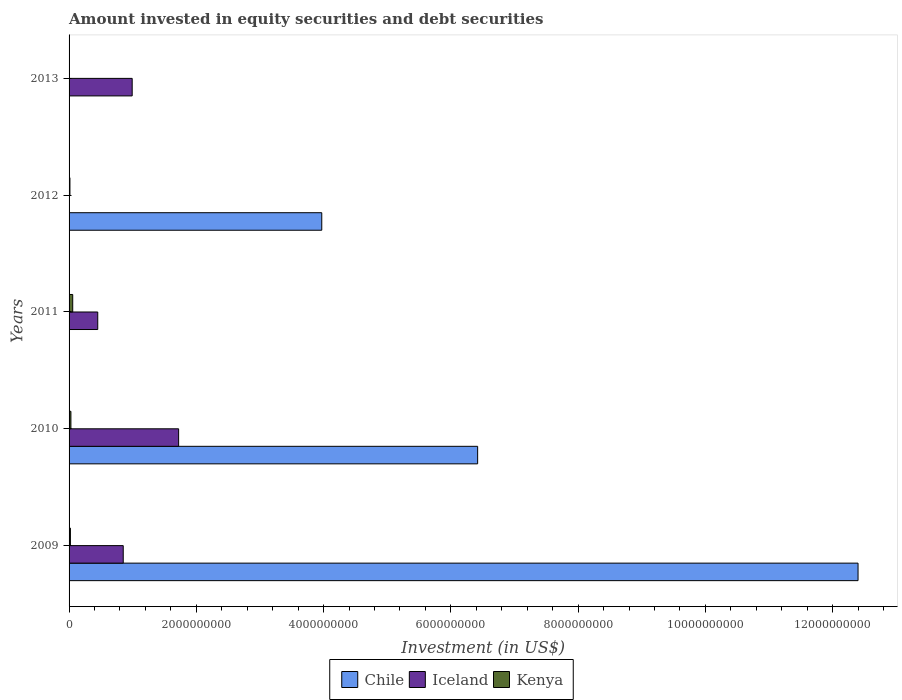How many different coloured bars are there?
Your answer should be very brief. 3. How many bars are there on the 3rd tick from the top?
Offer a terse response. 2. What is the amount invested in equity securities and debt securities in Kenya in 2009?
Provide a succinct answer. 2.09e+07. Across all years, what is the maximum amount invested in equity securities and debt securities in Iceland?
Provide a succinct answer. 1.72e+09. Across all years, what is the minimum amount invested in equity securities and debt securities in Kenya?
Your answer should be very brief. 0. What is the total amount invested in equity securities and debt securities in Iceland in the graph?
Keep it short and to the point. 4.02e+09. What is the difference between the amount invested in equity securities and debt securities in Kenya in 2011 and that in 2012?
Provide a succinct answer. 4.38e+07. What is the difference between the amount invested in equity securities and debt securities in Iceland in 2009 and the amount invested in equity securities and debt securities in Kenya in 2013?
Provide a succinct answer. 8.51e+08. What is the average amount invested in equity securities and debt securities in Kenya per year?
Make the answer very short. 2.42e+07. In the year 2009, what is the difference between the amount invested in equity securities and debt securities in Kenya and amount invested in equity securities and debt securities in Iceland?
Offer a very short reply. -8.30e+08. In how many years, is the amount invested in equity securities and debt securities in Iceland greater than 4000000000 US$?
Your answer should be compact. 0. What is the ratio of the amount invested in equity securities and debt securities in Kenya in 2009 to that in 2012?
Provide a short and direct response. 1.54. What is the difference between the highest and the second highest amount invested in equity securities and debt securities in Iceland?
Your answer should be compact. 7.30e+08. What is the difference between the highest and the lowest amount invested in equity securities and debt securities in Kenya?
Your answer should be compact. 5.74e+07. In how many years, is the amount invested in equity securities and debt securities in Iceland greater than the average amount invested in equity securities and debt securities in Iceland taken over all years?
Offer a very short reply. 3. Is the sum of the amount invested in equity securities and debt securities in Kenya in 2009 and 2011 greater than the maximum amount invested in equity securities and debt securities in Iceland across all years?
Provide a succinct answer. No. Is it the case that in every year, the sum of the amount invested in equity securities and debt securities in Kenya and amount invested in equity securities and debt securities in Iceland is greater than the amount invested in equity securities and debt securities in Chile?
Give a very brief answer. No. How many bars are there?
Make the answer very short. 11. Are all the bars in the graph horizontal?
Your answer should be very brief. Yes. How many years are there in the graph?
Provide a succinct answer. 5. What is the difference between two consecutive major ticks on the X-axis?
Make the answer very short. 2.00e+09. Are the values on the major ticks of X-axis written in scientific E-notation?
Make the answer very short. No. How many legend labels are there?
Provide a short and direct response. 3. What is the title of the graph?
Your answer should be compact. Amount invested in equity securities and debt securities. Does "Korea (Republic)" appear as one of the legend labels in the graph?
Offer a terse response. No. What is the label or title of the X-axis?
Your answer should be very brief. Investment (in US$). What is the Investment (in US$) in Chile in 2009?
Give a very brief answer. 1.24e+1. What is the Investment (in US$) of Iceland in 2009?
Offer a very short reply. 8.51e+08. What is the Investment (in US$) of Kenya in 2009?
Offer a very short reply. 2.09e+07. What is the Investment (in US$) in Chile in 2010?
Offer a terse response. 6.42e+09. What is the Investment (in US$) in Iceland in 2010?
Your answer should be compact. 1.72e+09. What is the Investment (in US$) in Kenya in 2010?
Give a very brief answer. 2.90e+07. What is the Investment (in US$) in Iceland in 2011?
Give a very brief answer. 4.51e+08. What is the Investment (in US$) in Kenya in 2011?
Give a very brief answer. 5.74e+07. What is the Investment (in US$) of Chile in 2012?
Give a very brief answer. 3.97e+09. What is the Investment (in US$) of Kenya in 2012?
Your answer should be compact. 1.36e+07. What is the Investment (in US$) of Chile in 2013?
Offer a very short reply. 0. What is the Investment (in US$) of Iceland in 2013?
Your response must be concise. 9.92e+08. Across all years, what is the maximum Investment (in US$) of Chile?
Give a very brief answer. 1.24e+1. Across all years, what is the maximum Investment (in US$) in Iceland?
Your response must be concise. 1.72e+09. Across all years, what is the maximum Investment (in US$) in Kenya?
Ensure brevity in your answer.  5.74e+07. Across all years, what is the minimum Investment (in US$) in Chile?
Offer a very short reply. 0. What is the total Investment (in US$) in Chile in the graph?
Provide a short and direct response. 2.28e+1. What is the total Investment (in US$) in Iceland in the graph?
Keep it short and to the point. 4.02e+09. What is the total Investment (in US$) in Kenya in the graph?
Your answer should be very brief. 1.21e+08. What is the difference between the Investment (in US$) in Chile in 2009 and that in 2010?
Offer a very short reply. 5.98e+09. What is the difference between the Investment (in US$) of Iceland in 2009 and that in 2010?
Offer a terse response. -8.70e+08. What is the difference between the Investment (in US$) of Kenya in 2009 and that in 2010?
Your response must be concise. -8.07e+06. What is the difference between the Investment (in US$) in Iceland in 2009 and that in 2011?
Your answer should be compact. 4.01e+08. What is the difference between the Investment (in US$) of Kenya in 2009 and that in 2011?
Your answer should be very brief. -3.65e+07. What is the difference between the Investment (in US$) in Chile in 2009 and that in 2012?
Your answer should be compact. 8.43e+09. What is the difference between the Investment (in US$) of Kenya in 2009 and that in 2012?
Keep it short and to the point. 7.29e+06. What is the difference between the Investment (in US$) in Iceland in 2009 and that in 2013?
Provide a succinct answer. -1.41e+08. What is the difference between the Investment (in US$) of Iceland in 2010 and that in 2011?
Provide a succinct answer. 1.27e+09. What is the difference between the Investment (in US$) in Kenya in 2010 and that in 2011?
Make the answer very short. -2.84e+07. What is the difference between the Investment (in US$) in Chile in 2010 and that in 2012?
Provide a short and direct response. 2.45e+09. What is the difference between the Investment (in US$) in Kenya in 2010 and that in 2012?
Your response must be concise. 1.54e+07. What is the difference between the Investment (in US$) of Iceland in 2010 and that in 2013?
Give a very brief answer. 7.30e+08. What is the difference between the Investment (in US$) of Kenya in 2011 and that in 2012?
Make the answer very short. 4.38e+07. What is the difference between the Investment (in US$) of Iceland in 2011 and that in 2013?
Offer a very short reply. -5.41e+08. What is the difference between the Investment (in US$) in Chile in 2009 and the Investment (in US$) in Iceland in 2010?
Your answer should be very brief. 1.07e+1. What is the difference between the Investment (in US$) of Chile in 2009 and the Investment (in US$) of Kenya in 2010?
Offer a very short reply. 1.24e+1. What is the difference between the Investment (in US$) of Iceland in 2009 and the Investment (in US$) of Kenya in 2010?
Make the answer very short. 8.22e+08. What is the difference between the Investment (in US$) in Chile in 2009 and the Investment (in US$) in Iceland in 2011?
Provide a succinct answer. 1.19e+1. What is the difference between the Investment (in US$) of Chile in 2009 and the Investment (in US$) of Kenya in 2011?
Provide a short and direct response. 1.23e+1. What is the difference between the Investment (in US$) of Iceland in 2009 and the Investment (in US$) of Kenya in 2011?
Give a very brief answer. 7.94e+08. What is the difference between the Investment (in US$) of Chile in 2009 and the Investment (in US$) of Kenya in 2012?
Your response must be concise. 1.24e+1. What is the difference between the Investment (in US$) in Iceland in 2009 and the Investment (in US$) in Kenya in 2012?
Provide a succinct answer. 8.38e+08. What is the difference between the Investment (in US$) of Chile in 2009 and the Investment (in US$) of Iceland in 2013?
Give a very brief answer. 1.14e+1. What is the difference between the Investment (in US$) of Chile in 2010 and the Investment (in US$) of Iceland in 2011?
Your answer should be very brief. 5.97e+09. What is the difference between the Investment (in US$) of Chile in 2010 and the Investment (in US$) of Kenya in 2011?
Ensure brevity in your answer.  6.36e+09. What is the difference between the Investment (in US$) in Iceland in 2010 and the Investment (in US$) in Kenya in 2011?
Your response must be concise. 1.66e+09. What is the difference between the Investment (in US$) in Chile in 2010 and the Investment (in US$) in Kenya in 2012?
Provide a short and direct response. 6.41e+09. What is the difference between the Investment (in US$) of Iceland in 2010 and the Investment (in US$) of Kenya in 2012?
Your response must be concise. 1.71e+09. What is the difference between the Investment (in US$) of Chile in 2010 and the Investment (in US$) of Iceland in 2013?
Make the answer very short. 5.43e+09. What is the difference between the Investment (in US$) in Iceland in 2011 and the Investment (in US$) in Kenya in 2012?
Your answer should be very brief. 4.37e+08. What is the difference between the Investment (in US$) of Chile in 2012 and the Investment (in US$) of Iceland in 2013?
Keep it short and to the point. 2.98e+09. What is the average Investment (in US$) in Chile per year?
Provide a succinct answer. 4.56e+09. What is the average Investment (in US$) in Iceland per year?
Provide a short and direct response. 8.03e+08. What is the average Investment (in US$) in Kenya per year?
Ensure brevity in your answer.  2.42e+07. In the year 2009, what is the difference between the Investment (in US$) in Chile and Investment (in US$) in Iceland?
Keep it short and to the point. 1.15e+1. In the year 2009, what is the difference between the Investment (in US$) of Chile and Investment (in US$) of Kenya?
Provide a short and direct response. 1.24e+1. In the year 2009, what is the difference between the Investment (in US$) in Iceland and Investment (in US$) in Kenya?
Offer a very short reply. 8.30e+08. In the year 2010, what is the difference between the Investment (in US$) of Chile and Investment (in US$) of Iceland?
Offer a very short reply. 4.70e+09. In the year 2010, what is the difference between the Investment (in US$) of Chile and Investment (in US$) of Kenya?
Ensure brevity in your answer.  6.39e+09. In the year 2010, what is the difference between the Investment (in US$) of Iceland and Investment (in US$) of Kenya?
Offer a terse response. 1.69e+09. In the year 2011, what is the difference between the Investment (in US$) in Iceland and Investment (in US$) in Kenya?
Offer a terse response. 3.93e+08. In the year 2012, what is the difference between the Investment (in US$) of Chile and Investment (in US$) of Kenya?
Offer a terse response. 3.96e+09. What is the ratio of the Investment (in US$) in Chile in 2009 to that in 2010?
Provide a succinct answer. 1.93. What is the ratio of the Investment (in US$) of Iceland in 2009 to that in 2010?
Your answer should be very brief. 0.49. What is the ratio of the Investment (in US$) in Kenya in 2009 to that in 2010?
Provide a succinct answer. 0.72. What is the ratio of the Investment (in US$) of Iceland in 2009 to that in 2011?
Your answer should be very brief. 1.89. What is the ratio of the Investment (in US$) of Kenya in 2009 to that in 2011?
Your response must be concise. 0.36. What is the ratio of the Investment (in US$) of Chile in 2009 to that in 2012?
Keep it short and to the point. 3.12. What is the ratio of the Investment (in US$) in Kenya in 2009 to that in 2012?
Keep it short and to the point. 1.54. What is the ratio of the Investment (in US$) in Iceland in 2009 to that in 2013?
Give a very brief answer. 0.86. What is the ratio of the Investment (in US$) of Iceland in 2010 to that in 2011?
Keep it short and to the point. 3.82. What is the ratio of the Investment (in US$) of Kenya in 2010 to that in 2011?
Your response must be concise. 0.5. What is the ratio of the Investment (in US$) in Chile in 2010 to that in 2012?
Give a very brief answer. 1.62. What is the ratio of the Investment (in US$) in Kenya in 2010 to that in 2012?
Offer a terse response. 2.13. What is the ratio of the Investment (in US$) of Iceland in 2010 to that in 2013?
Offer a terse response. 1.74. What is the ratio of the Investment (in US$) in Kenya in 2011 to that in 2012?
Ensure brevity in your answer.  4.22. What is the ratio of the Investment (in US$) in Iceland in 2011 to that in 2013?
Make the answer very short. 0.45. What is the difference between the highest and the second highest Investment (in US$) of Chile?
Make the answer very short. 5.98e+09. What is the difference between the highest and the second highest Investment (in US$) of Iceland?
Provide a short and direct response. 7.30e+08. What is the difference between the highest and the second highest Investment (in US$) of Kenya?
Keep it short and to the point. 2.84e+07. What is the difference between the highest and the lowest Investment (in US$) of Chile?
Your response must be concise. 1.24e+1. What is the difference between the highest and the lowest Investment (in US$) of Iceland?
Your answer should be compact. 1.72e+09. What is the difference between the highest and the lowest Investment (in US$) of Kenya?
Keep it short and to the point. 5.74e+07. 